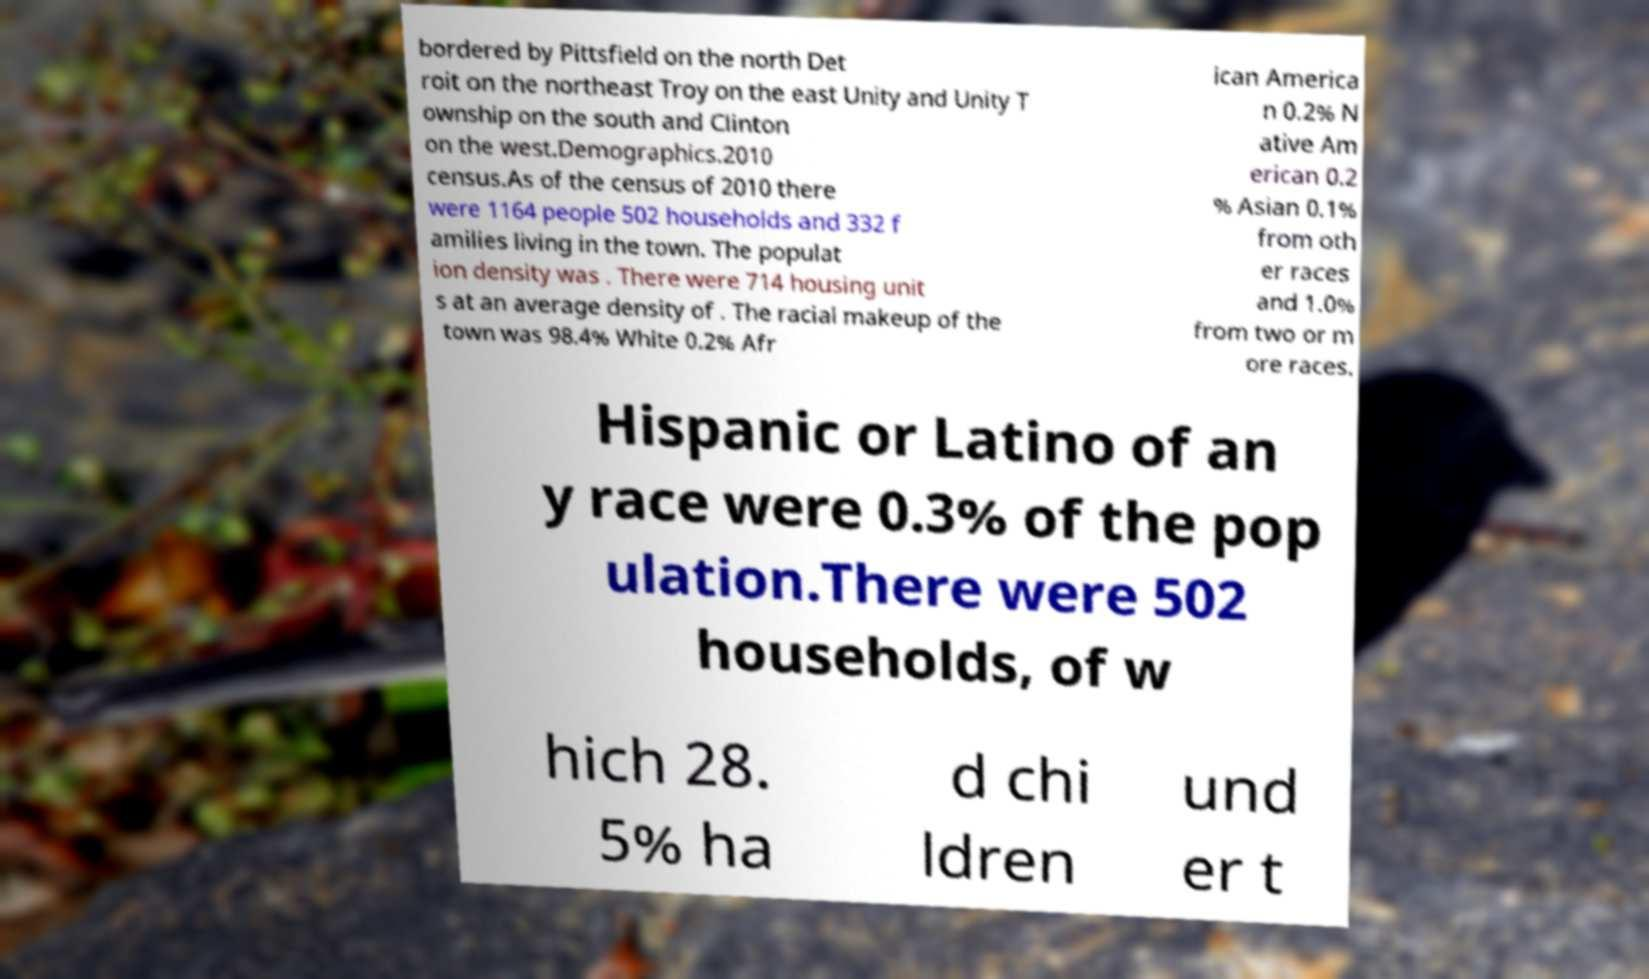Could you assist in decoding the text presented in this image and type it out clearly? bordered by Pittsfield on the north Det roit on the northeast Troy on the east Unity and Unity T ownship on the south and Clinton on the west.Demographics.2010 census.As of the census of 2010 there were 1164 people 502 households and 332 f amilies living in the town. The populat ion density was . There were 714 housing unit s at an average density of . The racial makeup of the town was 98.4% White 0.2% Afr ican America n 0.2% N ative Am erican 0.2 % Asian 0.1% from oth er races and 1.0% from two or m ore races. Hispanic or Latino of an y race were 0.3% of the pop ulation.There were 502 households, of w hich 28. 5% ha d chi ldren und er t 